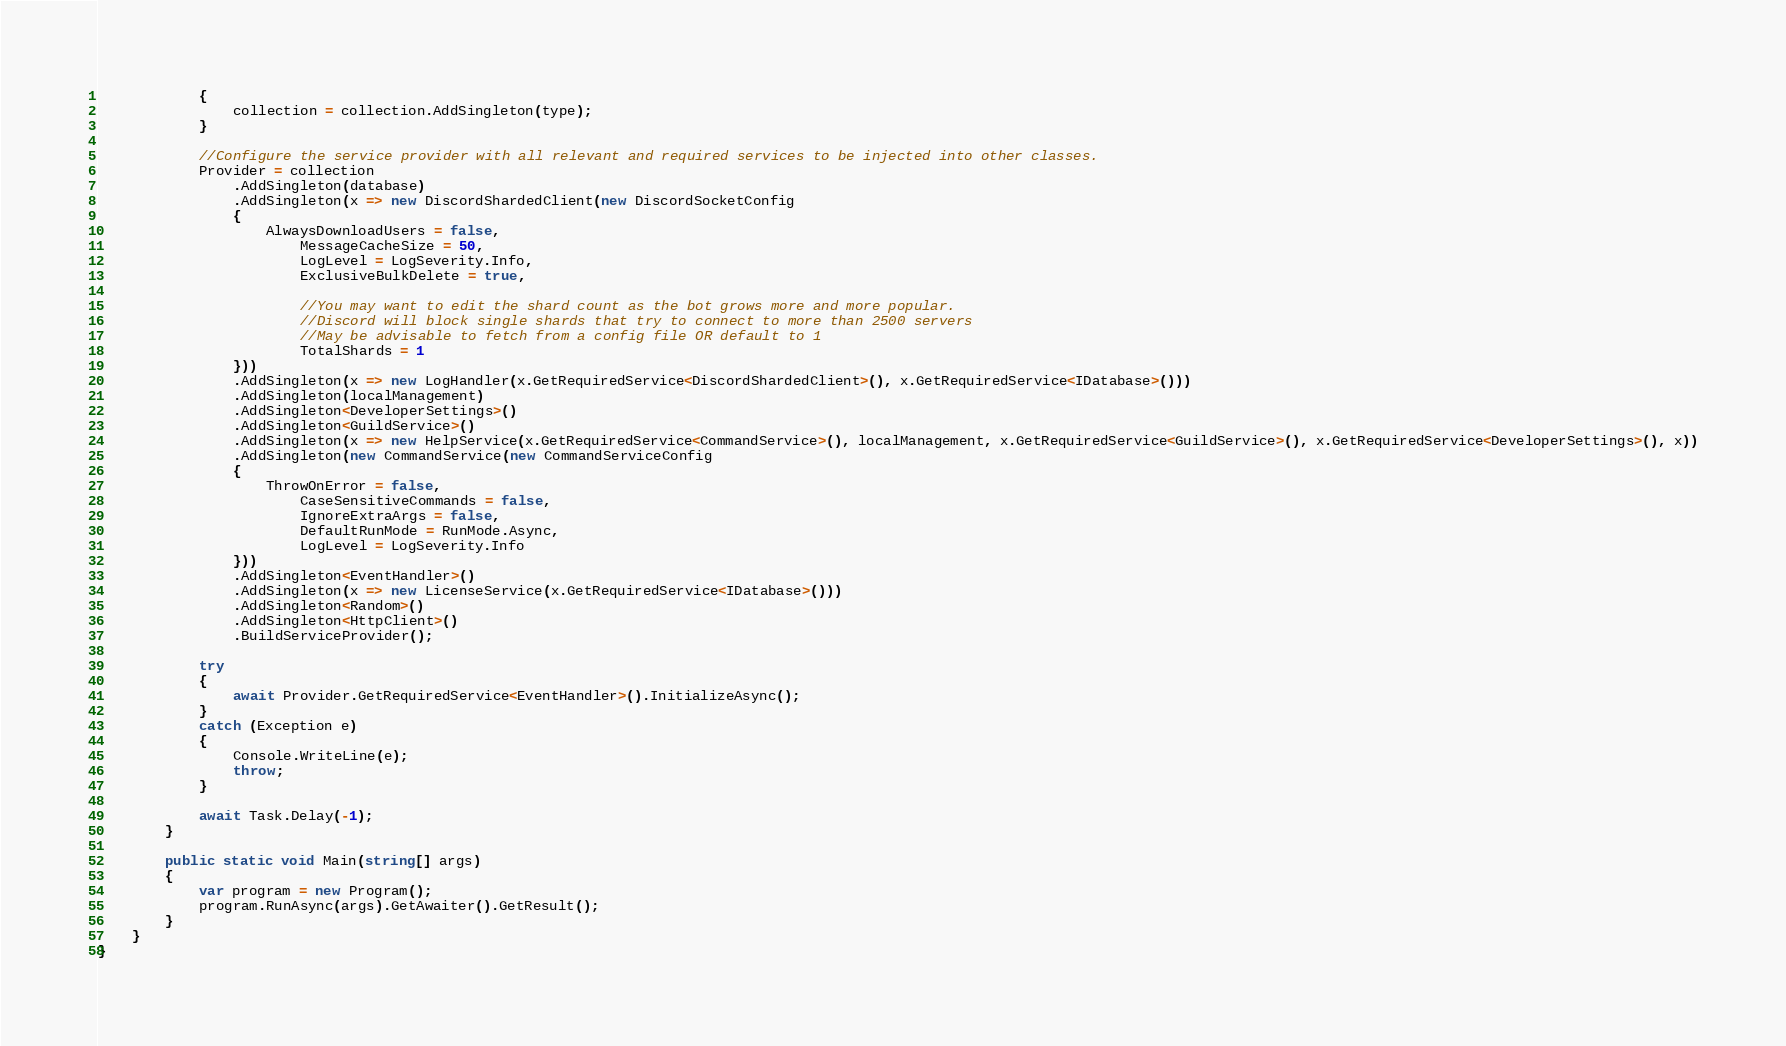Convert code to text. <code><loc_0><loc_0><loc_500><loc_500><_C#_>            {
                collection = collection.AddSingleton(type);
            }

            //Configure the service provider with all relevant and required services to be injected into other classes.
            Provider = collection
                .AddSingleton(database)
                .AddSingleton(x => new DiscordShardedClient(new DiscordSocketConfig
                {
                    AlwaysDownloadUsers = false,
                        MessageCacheSize = 50,
                        LogLevel = LogSeverity.Info,
                        ExclusiveBulkDelete = true,

                        //You may want to edit the shard count as the bot grows more and more popular.
                        //Discord will block single shards that try to connect to more than 2500 servers
                        //May be advisable to fetch from a config file OR default to 1
                        TotalShards = 1
                }))
                .AddSingleton(x => new LogHandler(x.GetRequiredService<DiscordShardedClient>(), x.GetRequiredService<IDatabase>()))
                .AddSingleton(localManagement)
                .AddSingleton<DeveloperSettings>()
                .AddSingleton<GuildService>()
                .AddSingleton(x => new HelpService(x.GetRequiredService<CommandService>(), localManagement, x.GetRequiredService<GuildService>(), x.GetRequiredService<DeveloperSettings>(), x))
                .AddSingleton(new CommandService(new CommandServiceConfig
                {
                    ThrowOnError = false,
                        CaseSensitiveCommands = false,
                        IgnoreExtraArgs = false,
                        DefaultRunMode = RunMode.Async,
                        LogLevel = LogSeverity.Info
                }))
                .AddSingleton<EventHandler>()
                .AddSingleton(x => new LicenseService(x.GetRequiredService<IDatabase>()))
                .AddSingleton<Random>()
                .AddSingleton<HttpClient>()
                .BuildServiceProvider();

            try
            {
                await Provider.GetRequiredService<EventHandler>().InitializeAsync();
            }
            catch (Exception e)
            {
                Console.WriteLine(e);
                throw;
            }

            await Task.Delay(-1);
        }

        public static void Main(string[] args)
        {
            var program = new Program();
            program.RunAsync(args).GetAwaiter().GetResult();
        }
    }
}</code> 